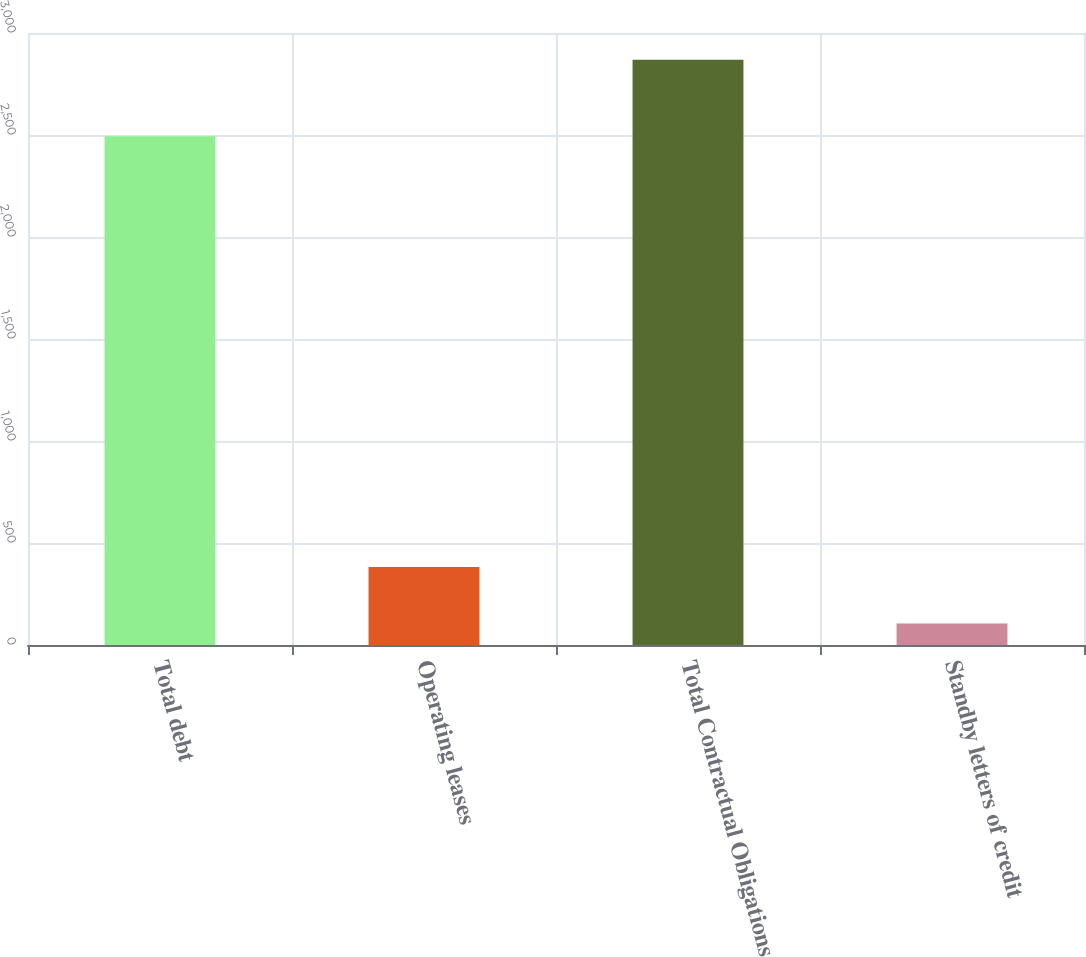Convert chart to OTSL. <chart><loc_0><loc_0><loc_500><loc_500><bar_chart><fcel>Total debt<fcel>Operating leases<fcel>Total Contractual Obligations<fcel>Standby letters of credit<nl><fcel>2494<fcel>382.3<fcel>2869<fcel>106<nl></chart> 